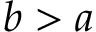Convert formula to latex. <formula><loc_0><loc_0><loc_500><loc_500>b > a</formula> 